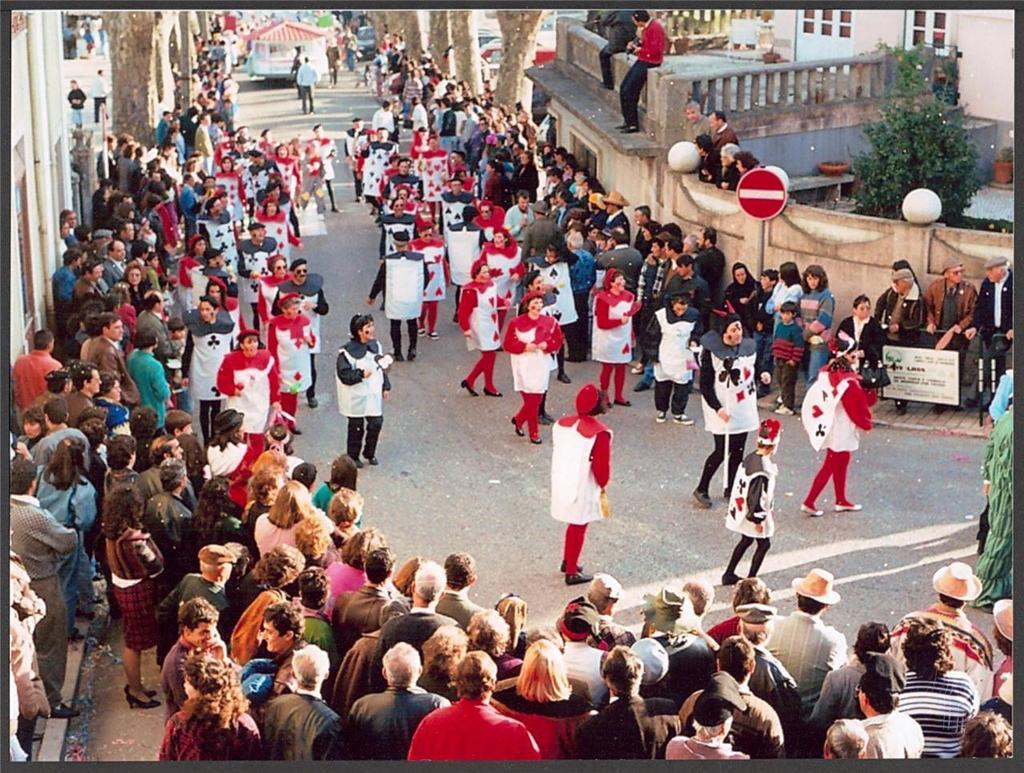What are the people in the image doing? The people in the image are standing and walking. What can be seen in the background of the image? In the background of the image, there are poles, sign boards, a wall, trees, and buildings. Can you describe the structures in the background? The background features poles, sign boards, and buildings. There is also a wall and trees visible. What type of mice can be seen writing on the sign boards in the image? There are no mice present in the image, and therefore no such activity can be observed. 